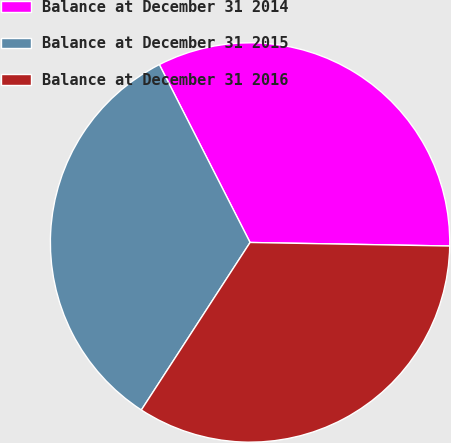Convert chart. <chart><loc_0><loc_0><loc_500><loc_500><pie_chart><fcel>Balance at December 31 2014<fcel>Balance at December 31 2015<fcel>Balance at December 31 2016<nl><fcel>32.79%<fcel>33.33%<fcel>33.88%<nl></chart> 